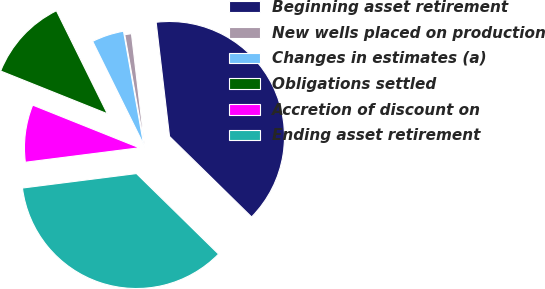Convert chart to OTSL. <chart><loc_0><loc_0><loc_500><loc_500><pie_chart><fcel>Beginning asset retirement<fcel>New wells placed on production<fcel>Changes in estimates (a)<fcel>Obligations settled<fcel>Accretion of discount on<fcel>Ending asset retirement<nl><fcel>39.2%<fcel>0.94%<fcel>4.51%<fcel>11.63%<fcel>8.07%<fcel>35.64%<nl></chart> 